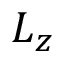<formula> <loc_0><loc_0><loc_500><loc_500>L _ { z }</formula> 